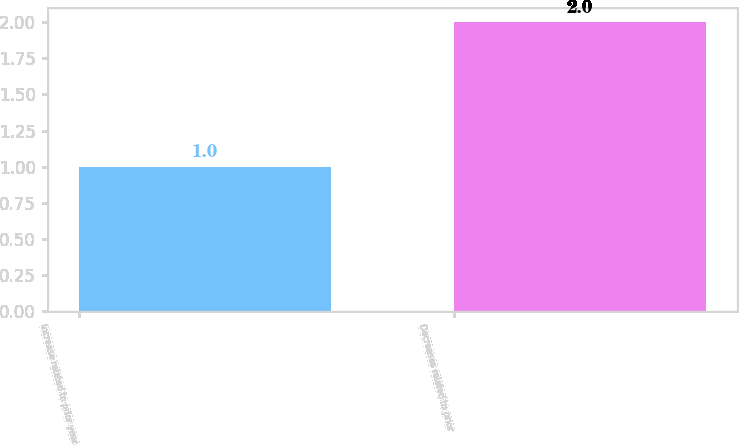Convert chart to OTSL. <chart><loc_0><loc_0><loc_500><loc_500><bar_chart><fcel>Increase related to prior year<fcel>Decreases related to prior<nl><fcel>1<fcel>2<nl></chart> 